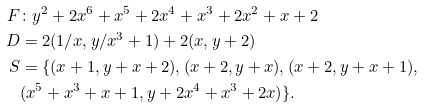<formula> <loc_0><loc_0><loc_500><loc_500>F & \colon y ^ { 2 } + 2 x ^ { 6 } + x ^ { 5 } + 2 x ^ { 4 } + x ^ { 3 } + 2 x ^ { 2 } + x + 2 \\ D & = 2 ( 1 / x , y / x ^ { 3 } + 1 ) + 2 ( x , y + 2 ) \\ S & = \{ ( x + 1 , y + x + 2 ) , ( x + 2 , y + x ) , ( x + 2 , y + x + 1 ) , \\ & ( x ^ { 5 } + x ^ { 3 } + x + 1 , y + 2 x ^ { 4 } + x ^ { 3 } + 2 x ) \} .</formula> 